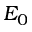Convert formula to latex. <formula><loc_0><loc_0><loc_500><loc_500>E _ { 0 }</formula> 